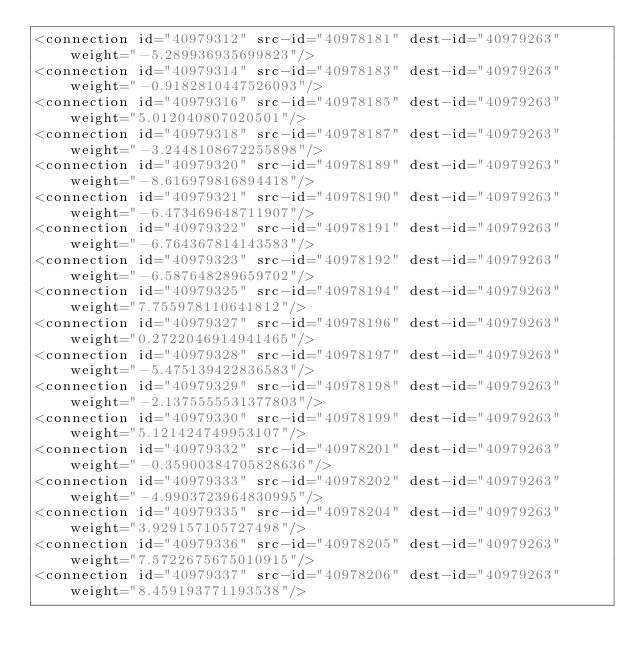Convert code to text. <code><loc_0><loc_0><loc_500><loc_500><_XML_><connection id="40979312" src-id="40978181" dest-id="40979263" weight="-5.289936935699823"/>
<connection id="40979314" src-id="40978183" dest-id="40979263" weight="-0.9182810447526093"/>
<connection id="40979316" src-id="40978185" dest-id="40979263" weight="5.012040807020501"/>
<connection id="40979318" src-id="40978187" dest-id="40979263" weight="-3.2448108672255898"/>
<connection id="40979320" src-id="40978189" dest-id="40979263" weight="-8.616979816894418"/>
<connection id="40979321" src-id="40978190" dest-id="40979263" weight="-6.473469648711907"/>
<connection id="40979322" src-id="40978191" dest-id="40979263" weight="-6.764367814143583"/>
<connection id="40979323" src-id="40978192" dest-id="40979263" weight="-6.587648289659702"/>
<connection id="40979325" src-id="40978194" dest-id="40979263" weight="7.755978110641812"/>
<connection id="40979327" src-id="40978196" dest-id="40979263" weight="0.2722046914941465"/>
<connection id="40979328" src-id="40978197" dest-id="40979263" weight="-5.475139422836583"/>
<connection id="40979329" src-id="40978198" dest-id="40979263" weight="-2.1375555531377803"/>
<connection id="40979330" src-id="40978199" dest-id="40979263" weight="5.121424749953107"/>
<connection id="40979332" src-id="40978201" dest-id="40979263" weight="-0.35900384705828636"/>
<connection id="40979333" src-id="40978202" dest-id="40979263" weight="-4.9903723964830995"/>
<connection id="40979335" src-id="40978204" dest-id="40979263" weight="3.929157105727498"/>
<connection id="40979336" src-id="40978205" dest-id="40979263" weight="7.5722675675010915"/>
<connection id="40979337" src-id="40978206" dest-id="40979263" weight="8.459193771193538"/></code> 